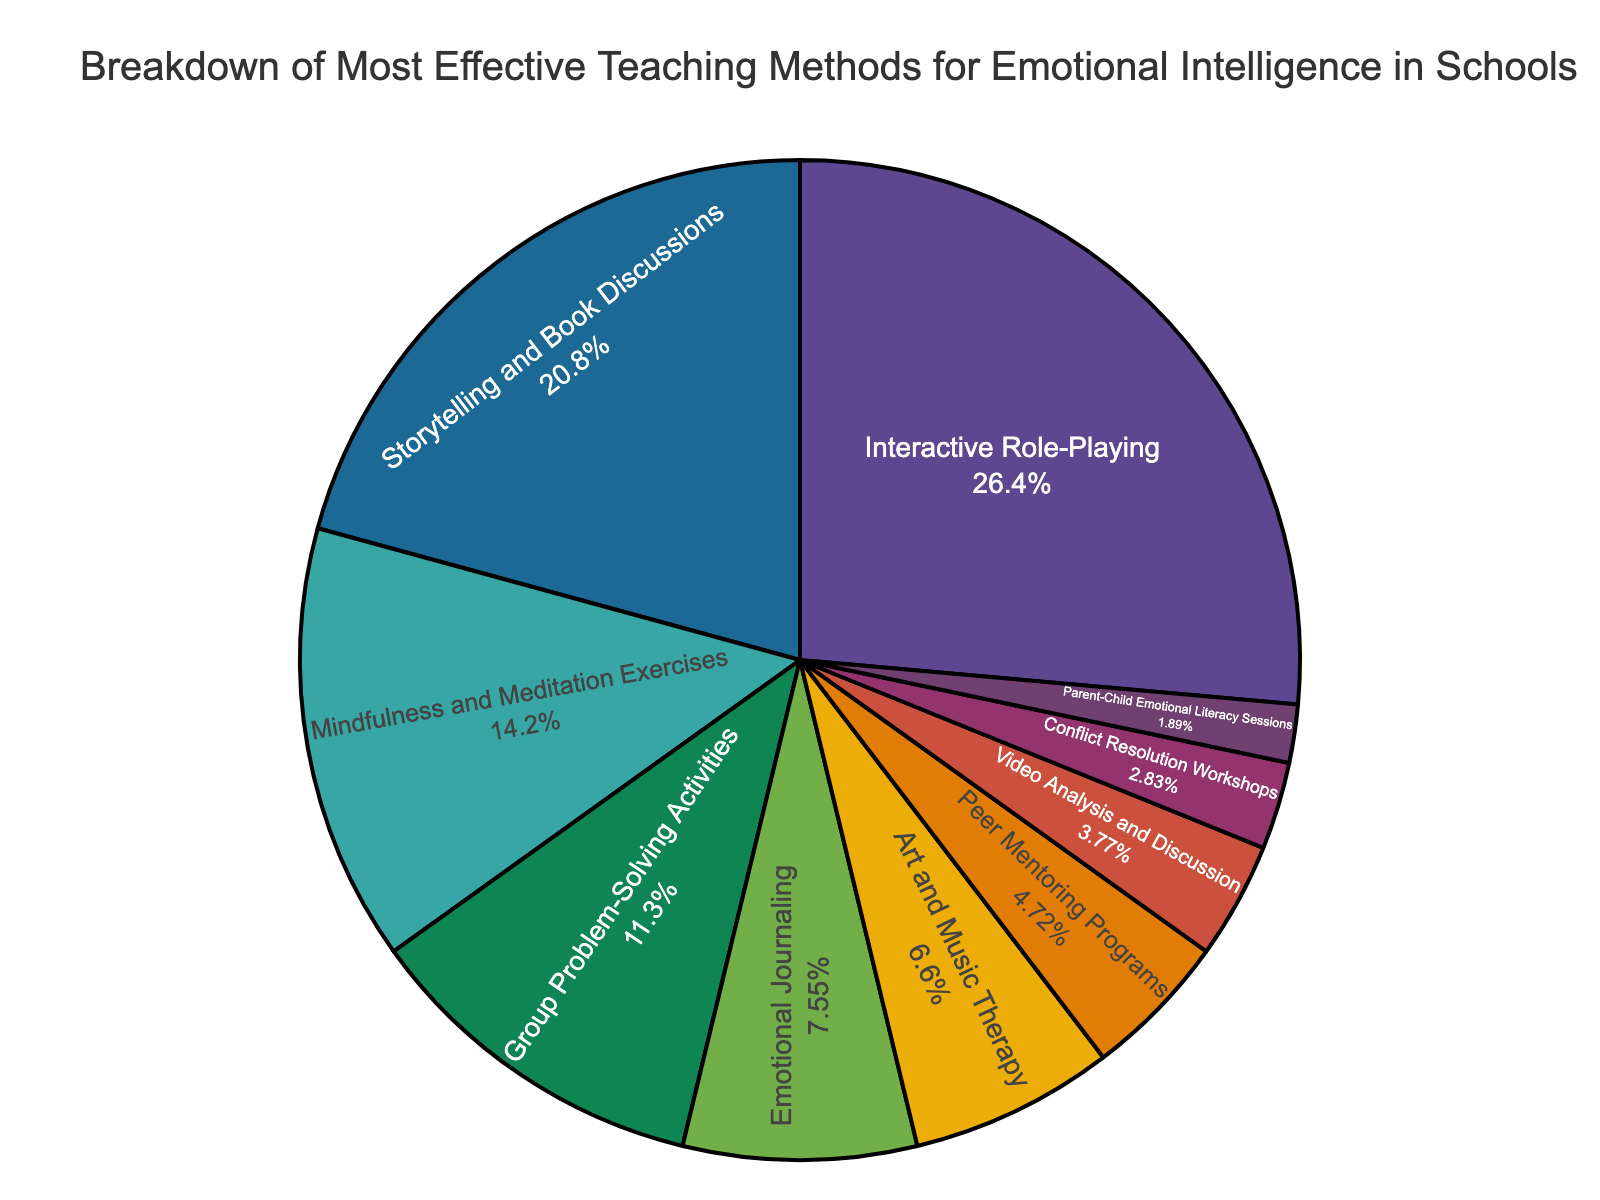What's the most effective teaching method for emotional intelligence according to the chart? The chart indicates that "Interactive Role-Playing" has the largest segment, which implies it is the most effective method.
Answer: Interactive Role-Playing Which two teaching methods have the closest percentage values? Looking at the chart segments, "Art and Music Therapy" (7%) and "Peer Mentoring Programs" (5%) have the closest values as their percentages are very near each other.
Answer: Art and Music Therapy, Peer Mentoring Programs What is the combined percentage of "Interactive Role-Playing" and "Storytelling and Book Discussions"? Adding the percentages of "Interactive Role-Playing" (28%) and "Storytelling and Book Discussions" (22%) results in 28 + 22 = 50.
Answer: 50% Which teaching method has the smallest percentage and what is it? The smallest segment in the chart is for "Parent-Child Emotional Literacy Sessions," which is 2%.
Answer: Parent-Child Emotional Literacy Sessions, 2% How much larger is the percentage of "Mindfulness and Meditation Exercises" compared to "Group Problem-Solving Activities"? The percentage of "Mindfulness and Meditation Exercises" is 15%, and "Group Problem-Solving Activities" is 12%. The difference is 15 - 12 = 3.
Answer: 3% What are the teaching methods that sum to less than 10% individually, and what do they total combined? The methods under 10% are "Emotional Journaling" (8%), "Art and Music Therapy" (7%), "Peer Mentoring Programs" (5%), "Video Analysis and Discussion" (4%), "Conflict Resolution Workshops" (3%), and "Parent-Child Emotional Literacy Sessions" (2%). Adding these together: 8 + 7 + 5 + 4 + 3 + 2 = 29.
Answer: Emotional Journaling, Art and Music Therapy, Peer Mentoring Programs, Video Analysis and Discussion, Conflict Resolution Workshops, Parent-Child Emotional Literacy Sessions; 29% Which methods are less than 10% and total exactly 10% combined? Reviewing the chart, "Video Analysis and Discussion" (4%), "Conflict Resolution Workshops" (3%), and "Parent-Child Emotional Literacy Sessions" (2%) total: 4 + 3 + 2 = 9, which does not match. Thus, no exact combination of methods under 10% totals exactly 10%.
Answer: None 